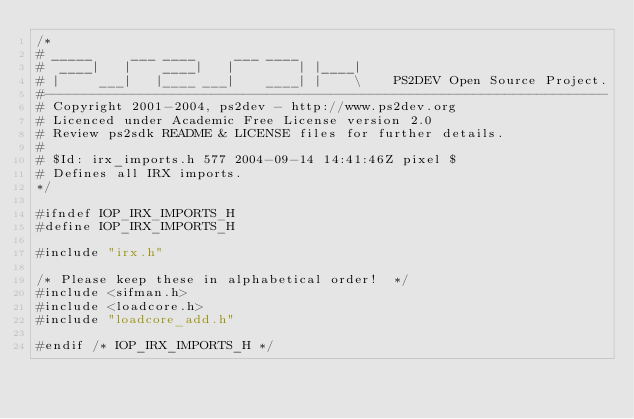<code> <loc_0><loc_0><loc_500><loc_500><_C_>/*
# _____     ___ ____     ___ ____
#  ____|   |    ____|   |        | |____|
# |     ___|   |____ ___|    ____| |    \    PS2DEV Open Source Project.
#-----------------------------------------------------------------------
# Copyright 2001-2004, ps2dev - http://www.ps2dev.org
# Licenced under Academic Free License version 2.0
# Review ps2sdk README & LICENSE files for further details.
#
# $Id: irx_imports.h 577 2004-09-14 14:41:46Z pixel $
# Defines all IRX imports.
*/

#ifndef IOP_IRX_IMPORTS_H
#define IOP_IRX_IMPORTS_H

#include "irx.h"

/* Please keep these in alphabetical order!  */
#include <sifman.h>
#include <loadcore.h>
#include "loadcore_add.h"

#endif /* IOP_IRX_IMPORTS_H */
</code> 